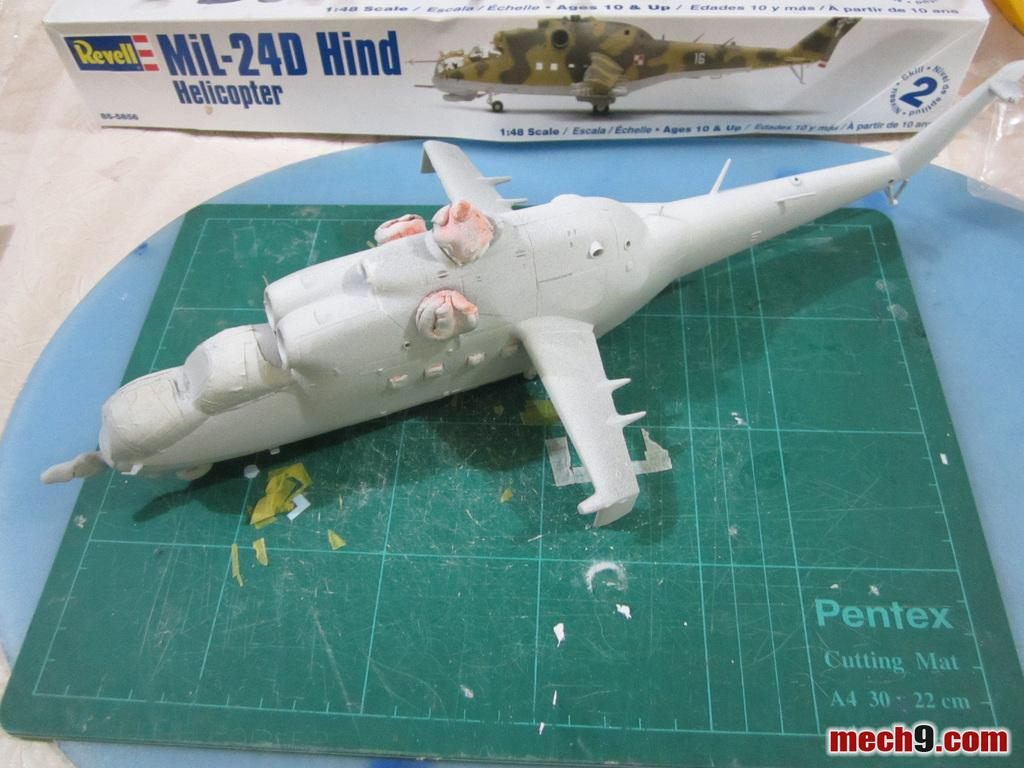<image>
Describe the image concisely. Revell model helocopter being put together on a green mat 